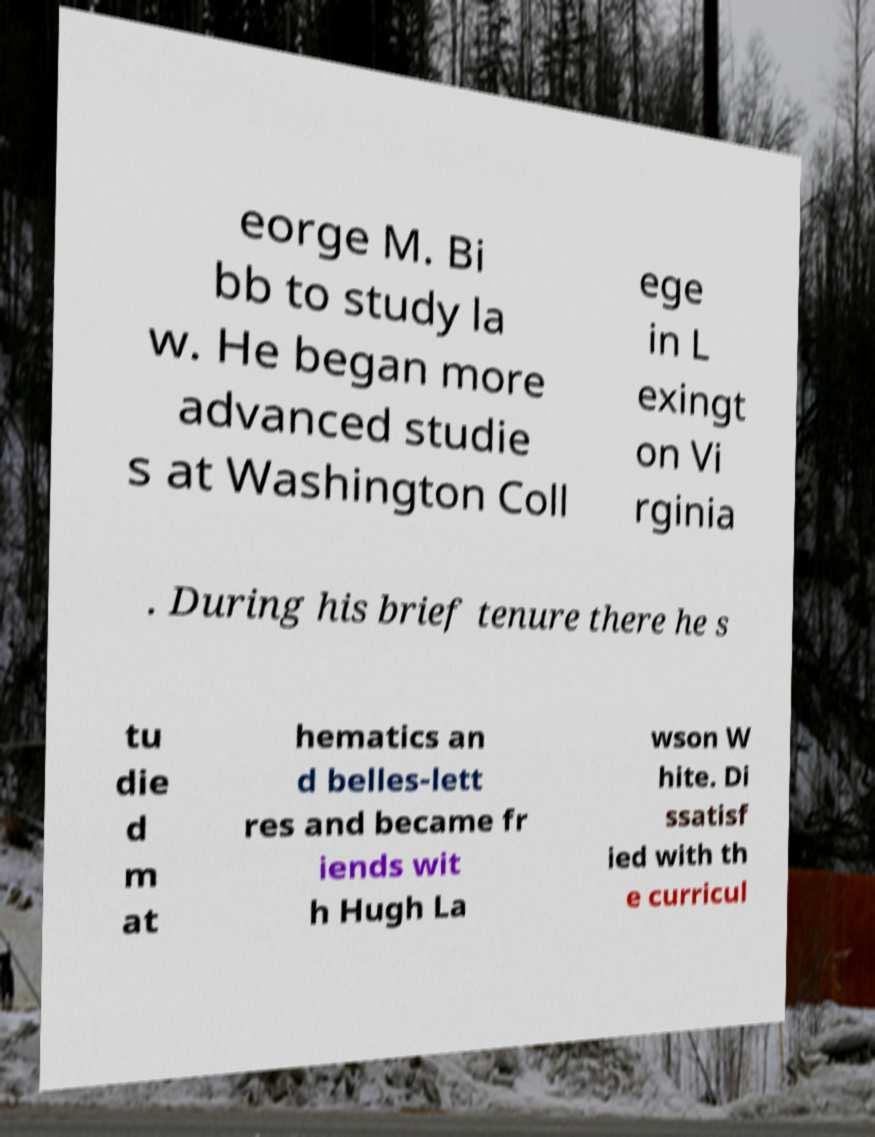Can you read and provide the text displayed in the image?This photo seems to have some interesting text. Can you extract and type it out for me? eorge M. Bi bb to study la w. He began more advanced studie s at Washington Coll ege in L exingt on Vi rginia . During his brief tenure there he s tu die d m at hematics an d belles-lett res and became fr iends wit h Hugh La wson W hite. Di ssatisf ied with th e curricul 